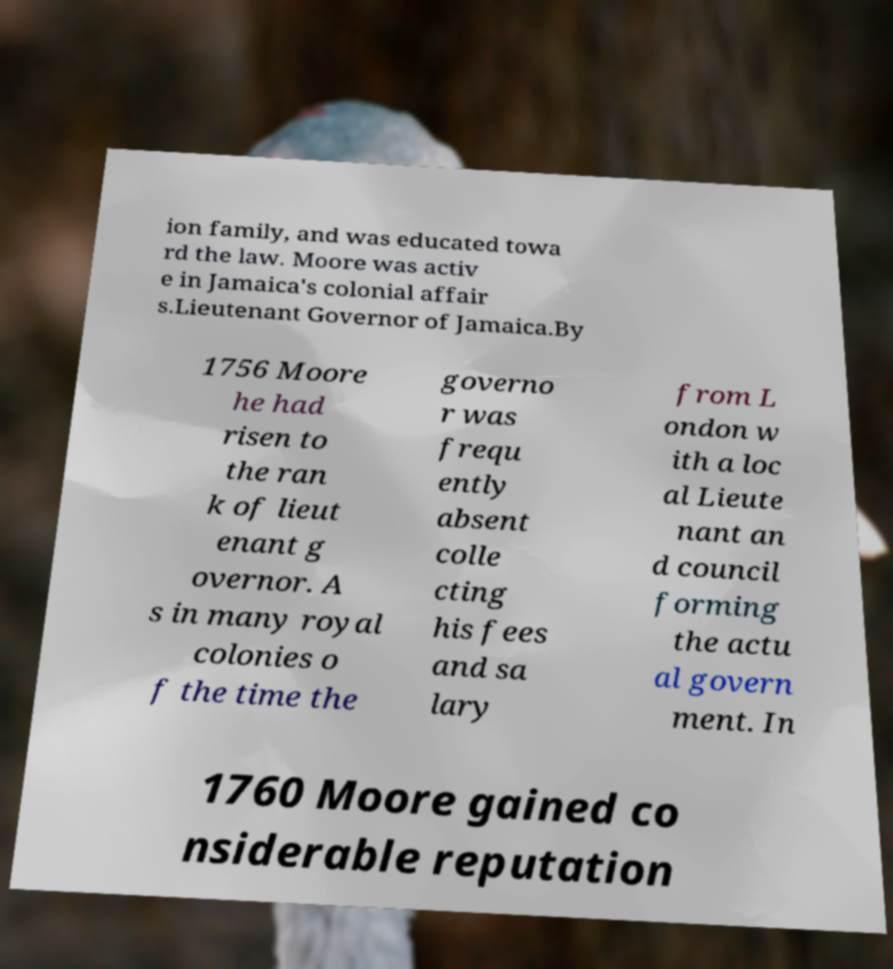There's text embedded in this image that I need extracted. Can you transcribe it verbatim? ion family, and was educated towa rd the law. Moore was activ e in Jamaica's colonial affair s.Lieutenant Governor of Jamaica.By 1756 Moore he had risen to the ran k of lieut enant g overnor. A s in many royal colonies o f the time the governo r was frequ ently absent colle cting his fees and sa lary from L ondon w ith a loc al Lieute nant an d council forming the actu al govern ment. In 1760 Moore gained co nsiderable reputation 